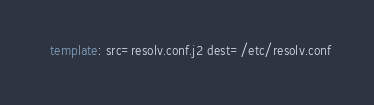Convert code to text. <code><loc_0><loc_0><loc_500><loc_500><_YAML_>  template: src=resolv.conf.j2 dest=/etc/resolv.conf
</code> 